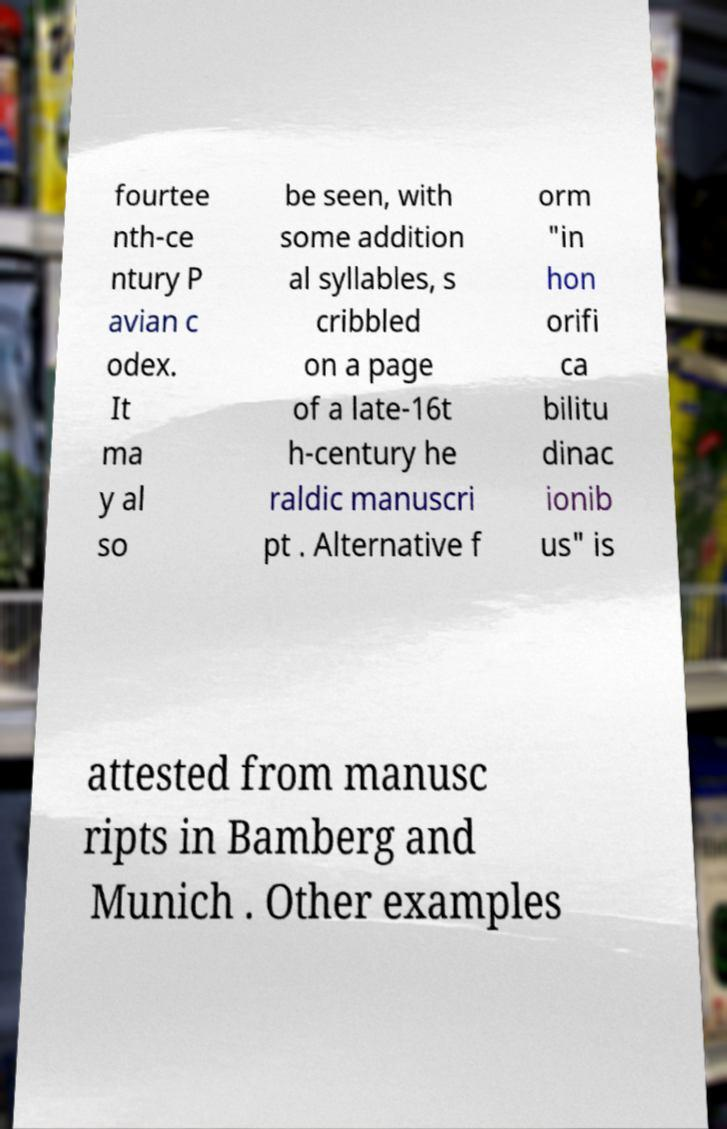Could you extract and type out the text from this image? fourtee nth-ce ntury P avian c odex. It ma y al so be seen, with some addition al syllables, s cribbled on a page of a late-16t h-century he raldic manuscri pt . Alternative f orm "in hon orifi ca bilitu dinac ionib us" is attested from manusc ripts in Bamberg and Munich . Other examples 